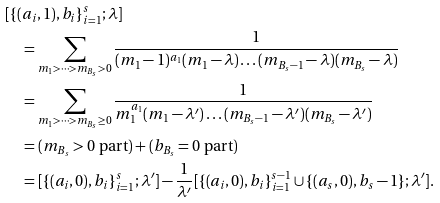<formula> <loc_0><loc_0><loc_500><loc_500>& [ \{ ( a _ { i } , 1 ) , b _ { i } \} _ { i = 1 } ^ { s } ; \lambda ] \\ & \quad = \sum _ { m _ { 1 } > \dots > m _ { B _ { s } } > 0 } \frac { 1 } { ( m _ { 1 } - 1 ) ^ { a _ { 1 } } ( m _ { 1 } - \lambda ) \dots ( m _ { B _ { s } - 1 } - \lambda ) ( m _ { B _ { s } } - \lambda ) } \\ & \quad = \sum _ { m _ { 1 } > \dots > m _ { B _ { s } } \geq 0 } \frac { 1 } { m _ { 1 } ^ { a _ { 1 } } ( m _ { 1 } - \lambda ^ { \prime } ) \dots ( m _ { B _ { s } - 1 } - \lambda ^ { \prime } ) ( m _ { B _ { s } } - \lambda ^ { \prime } ) } \\ & \quad = ( \text {$m_{B_{s}}>0$ part} ) + ( \text {$b_{B_{s}}=0$ part} ) \\ & \quad = [ \{ ( a _ { i } , 0 ) , b _ { i } \} _ { i = 1 } ^ { s } ; \lambda ^ { \prime } ] - \frac { 1 } { \lambda ^ { \prime } } [ \{ ( a _ { i } , 0 ) , b _ { i } \} _ { i = 1 } ^ { s - 1 } \cup \{ ( a _ { s } , 0 ) , b _ { s } - 1 \} ; \lambda ^ { \prime } ] .</formula> 